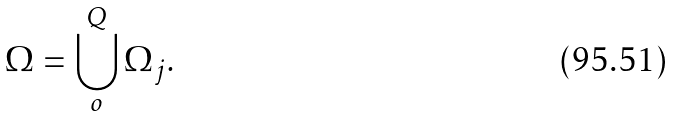Convert formula to latex. <formula><loc_0><loc_0><loc_500><loc_500>\Omega = \bigcup _ { o } ^ { Q } \Omega _ { j } .</formula> 